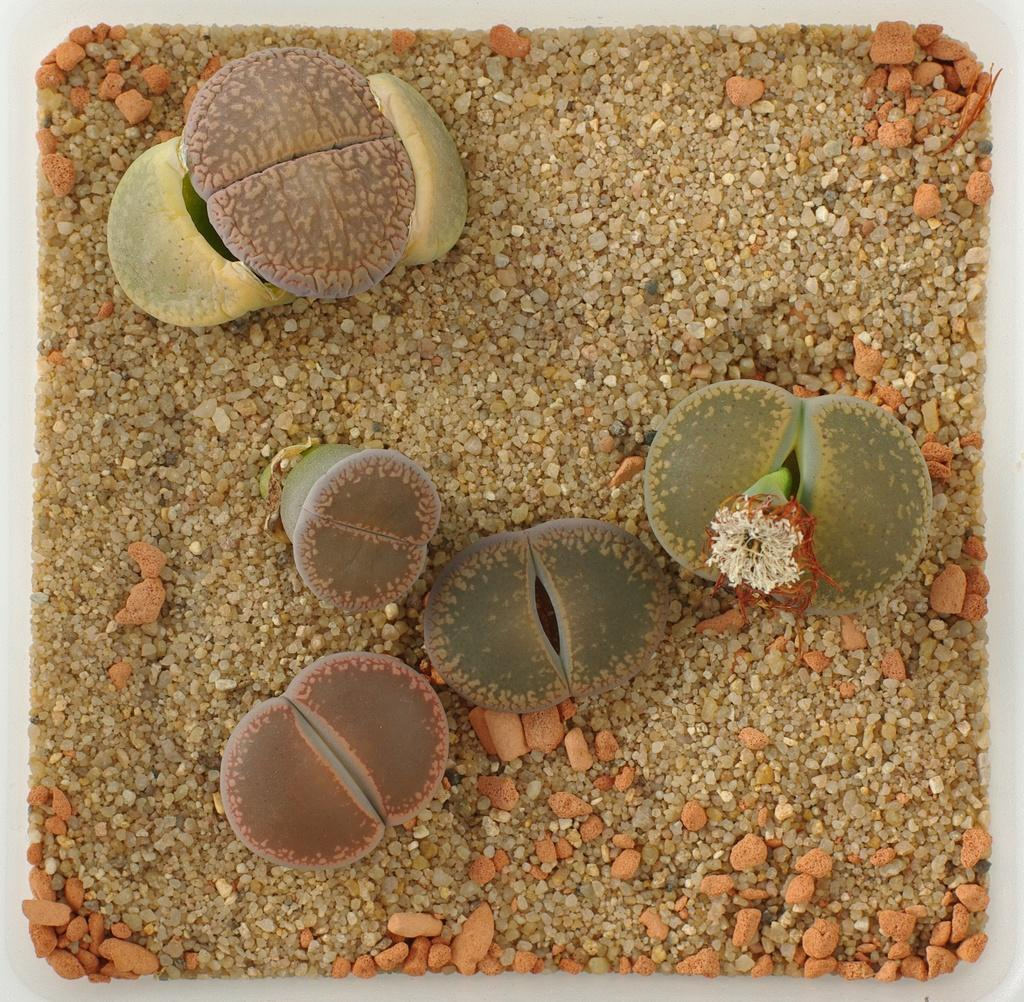What type of living organisms can be seen in the image? Plants and a flower can be seen in the image. What type of inanimate objects are present in the image? Stones are present in the image. What type of advice can be seen written on the flower in the image? There is no advice written on the flower in the image, as it is a living organism and not a surface for writing. 